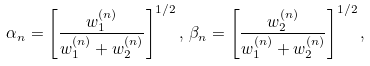Convert formula to latex. <formula><loc_0><loc_0><loc_500><loc_500>\alpha _ { n } = \left [ \frac { w _ { 1 } ^ { ( n ) } } { w _ { 1 } ^ { ( n ) } + w _ { 2 } ^ { ( n ) } } \right ] ^ { 1 / 2 } , \, \beta _ { n } = \left [ \frac { w _ { 2 } ^ { ( n ) } } { w _ { 1 } ^ { ( n ) } + w _ { 2 } ^ { ( n ) } } \right ] ^ { 1 / 2 } ,</formula> 